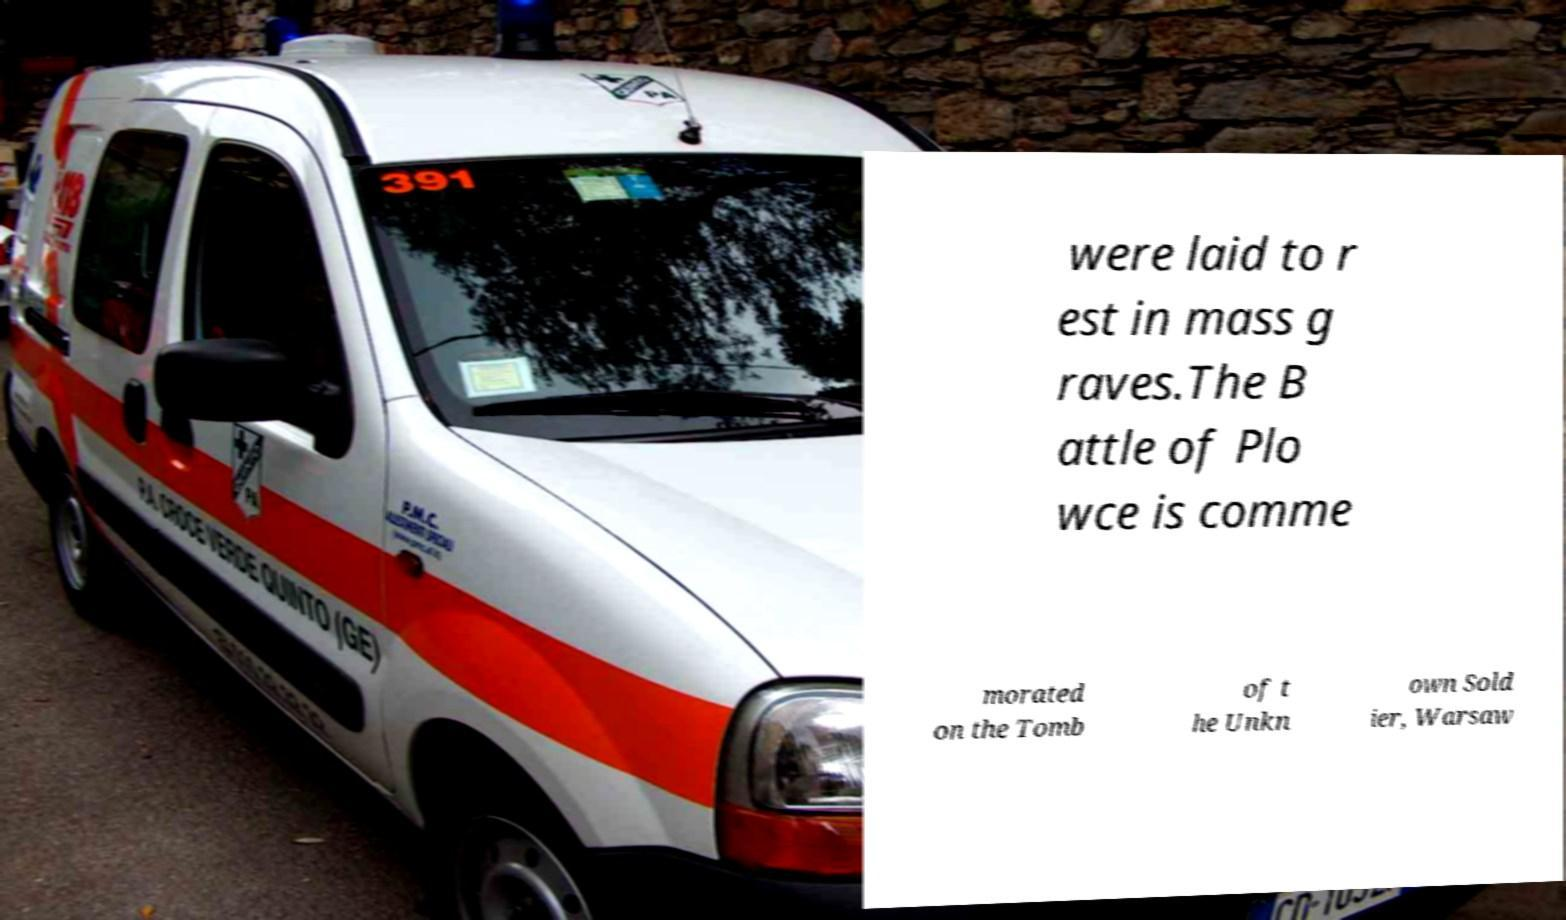Could you assist in decoding the text presented in this image and type it out clearly? were laid to r est in mass g raves.The B attle of Plo wce is comme morated on the Tomb of t he Unkn own Sold ier, Warsaw 